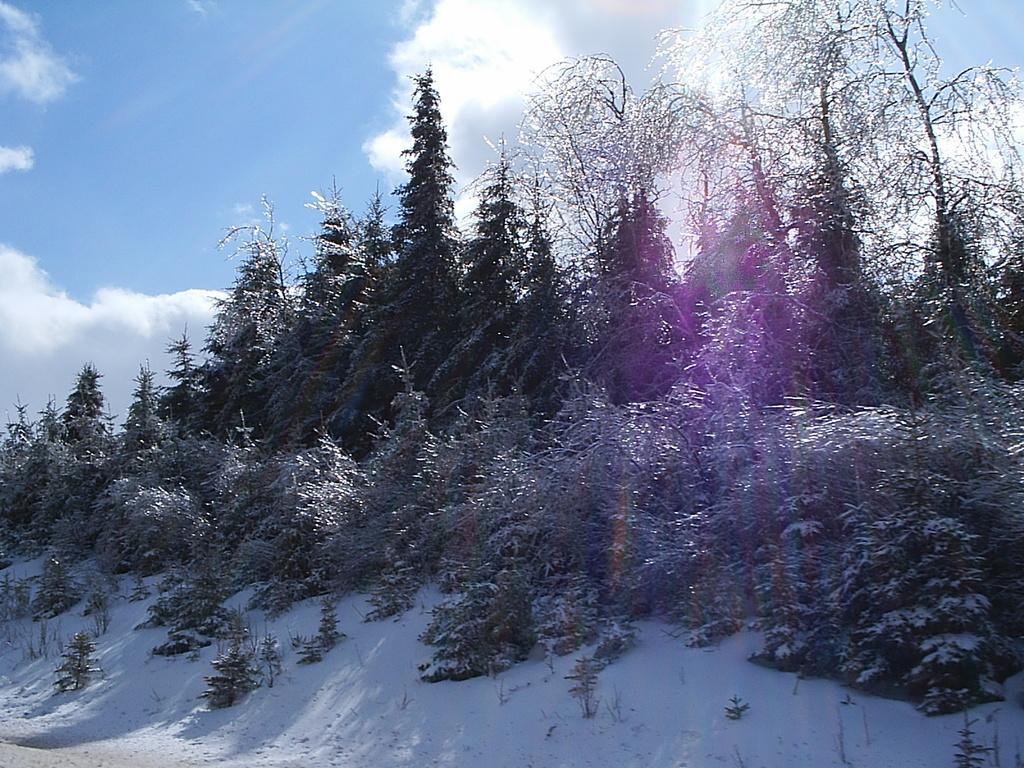What type of vegetation can be seen in the image? There are trees in the image. What is visible in the background of the image? The sky is visible in the image. What can be observed in the sky? Clouds are present in the sky. What type of order is being placed by the trees in the image? There is no indication in the image that the trees are placing an order, as trees do not have the ability to place orders. 